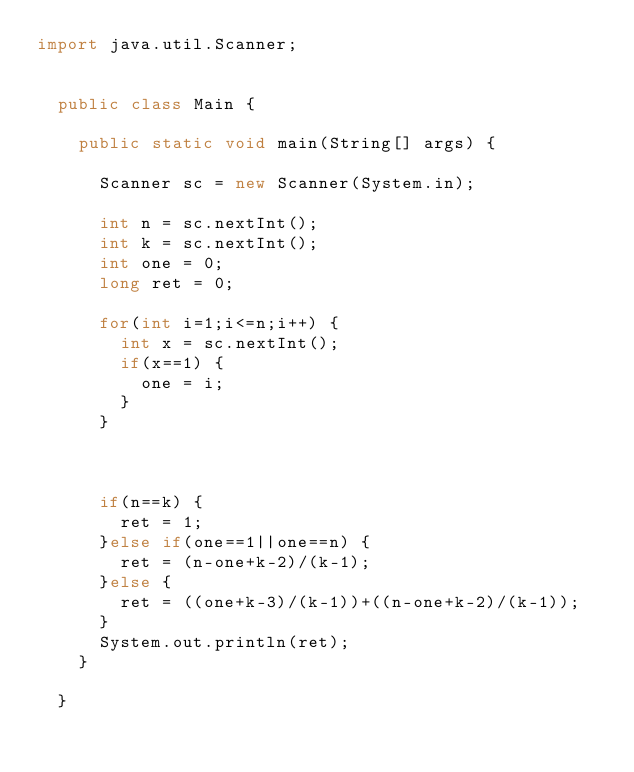<code> <loc_0><loc_0><loc_500><loc_500><_Java_>import java.util.Scanner;


	public class Main {

		public static void main(String[] args) {

			Scanner sc = new Scanner(System.in);

			int n = sc.nextInt();
			int k = sc.nextInt();
			int one = 0;
			long ret = 0;
			
			for(int i=1;i<=n;i++) {
				int x = sc.nextInt();
				if(x==1) {
					one = i;
				}
			}
			
			
			
			if(n==k) {
				ret = 1;
			}else if(one==1||one==n) {
				ret = (n-one+k-2)/(k-1);				
			}else {
				ret = ((one+k-3)/(k-1))+((n-one+k-2)/(k-1));
			}
			System.out.println(ret);
		}

	}
</code> 